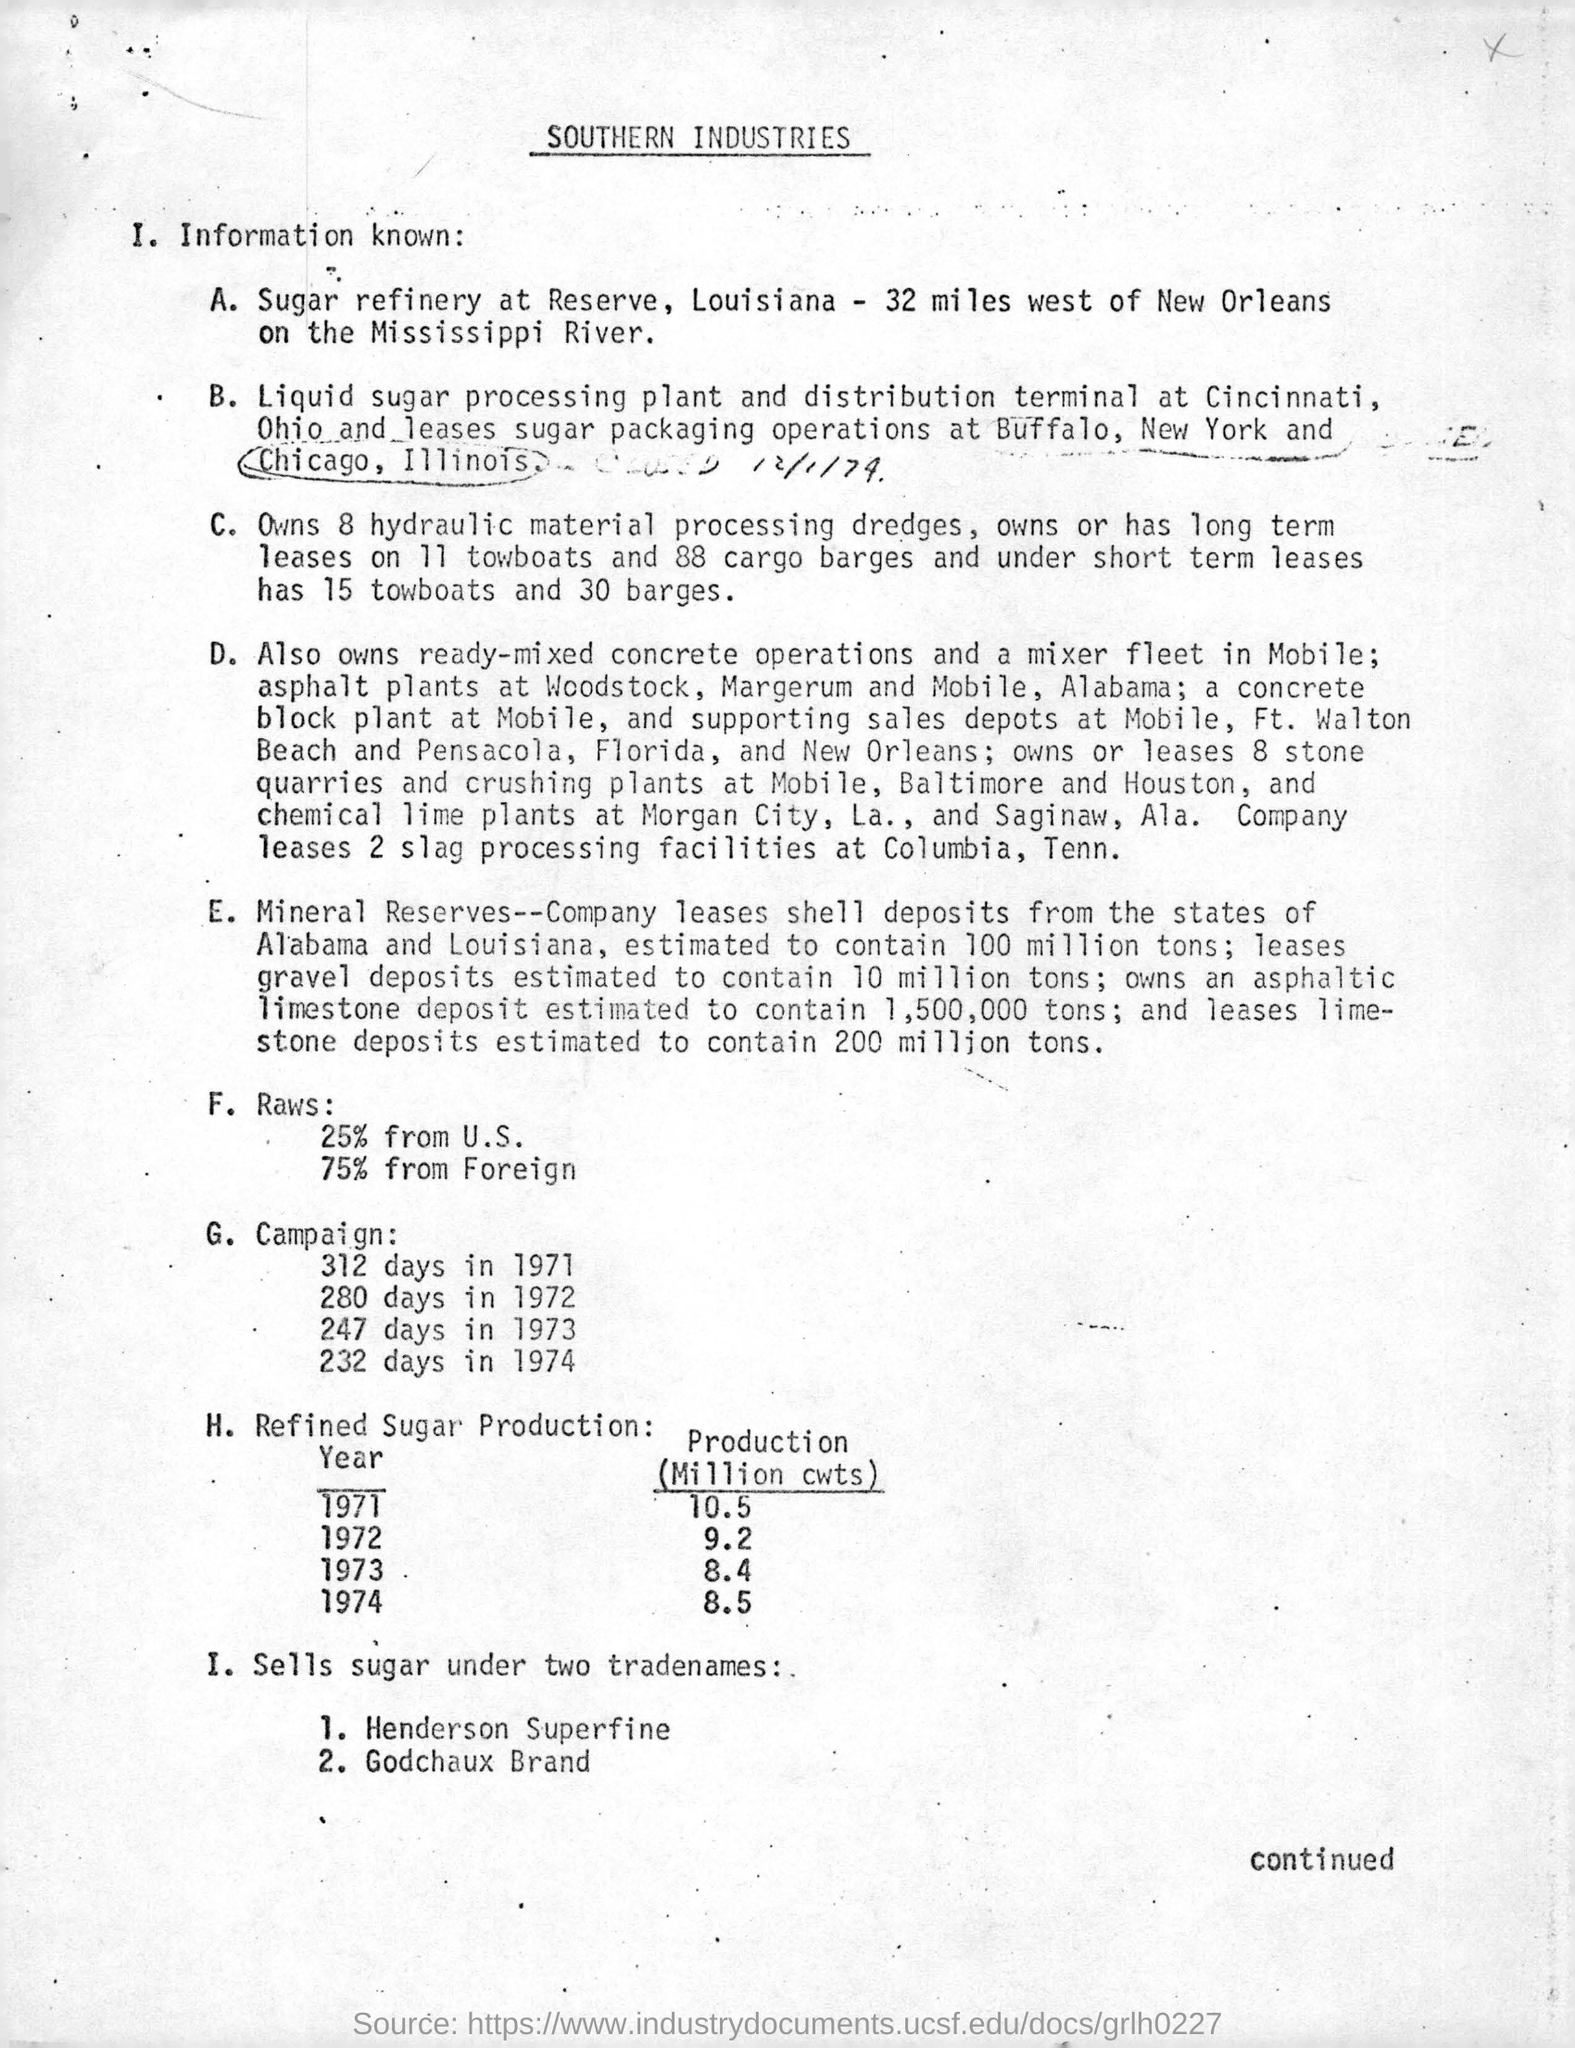Which year has the lowest production (million cwts) of refined sugar?
Ensure brevity in your answer.  1973. How many hydraulic material processing dredges are owned?
Offer a terse response. Owns 8 hydraulic material processing dredges. What is the production (million cwts) of refined sugar in the year 1971?
Offer a terse response. 10.5. How much is the refined sugar production in 1974?
Keep it short and to the point. 8.5 Million cwts. 